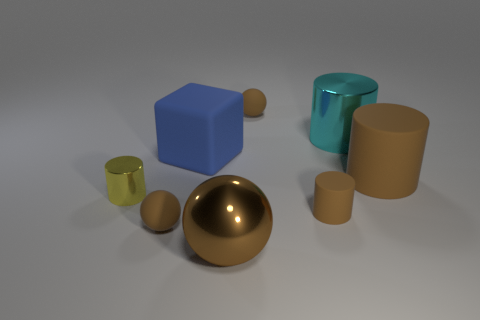Add 1 brown matte spheres. How many objects exist? 9 Subtract all small yellow shiny cylinders. How many cylinders are left? 3 Subtract all cubes. How many objects are left? 7 Subtract all gray cubes. How many brown cylinders are left? 2 Subtract all yellow cylinders. How many cylinders are left? 3 Subtract 1 balls. How many balls are left? 2 Subtract 0 purple cylinders. How many objects are left? 8 Subtract all gray spheres. Subtract all red cylinders. How many spheres are left? 3 Subtract all tiny red cubes. Subtract all brown matte cylinders. How many objects are left? 6 Add 5 small brown cylinders. How many small brown cylinders are left? 6 